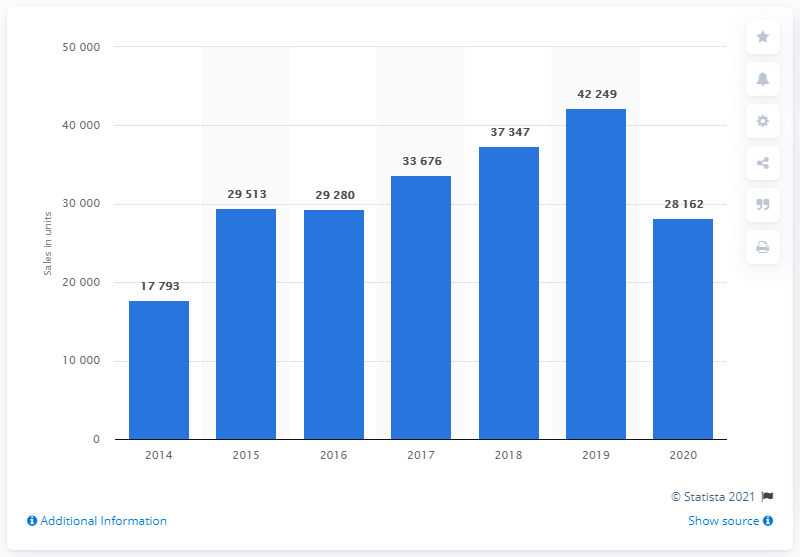Outline some significant characteristics in this image. The BMW i series was first sold in the year 2014. 